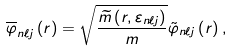Convert formula to latex. <formula><loc_0><loc_0><loc_500><loc_500>\overline { \varphi } _ { n \ell j } \left ( r \right ) = \sqrt { \frac { \widetilde { m } \left ( r , \varepsilon _ { n \ell j } \right ) } { m } } \tilde { \varphi } _ { n \ell j } \left ( r \right ) ,</formula> 